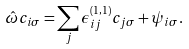Convert formula to latex. <formula><loc_0><loc_0><loc_500><loc_500>\hat { \omega } c _ { i \sigma } = \sum _ { j } \epsilon ^ { ( 1 , 1 ) } _ { i j } c _ { j \sigma } + \psi _ { i \sigma } .</formula> 